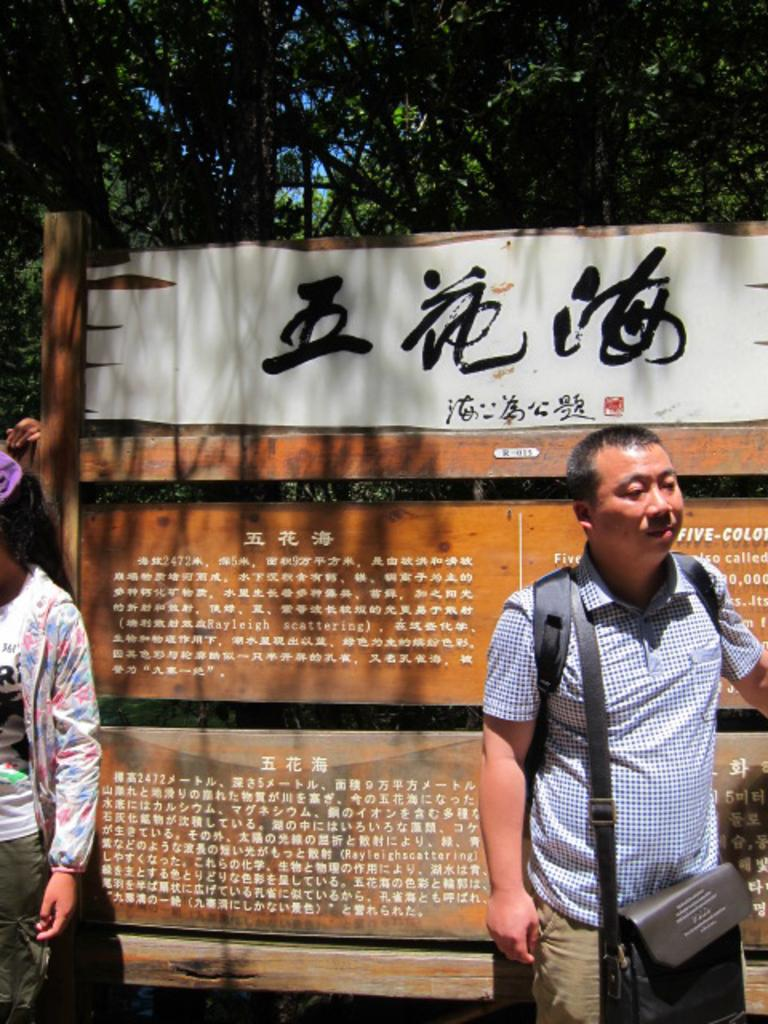How many people are present in the image? There are two people in the image. What are the people doing in the image? The people are standing on the road. What can be seen in the background of the image? There is a hoarding and trees in the background of the image. What type of coil is wrapped around the trees in the image? There is no coil present in the image; the trees are simply visible in the background. 